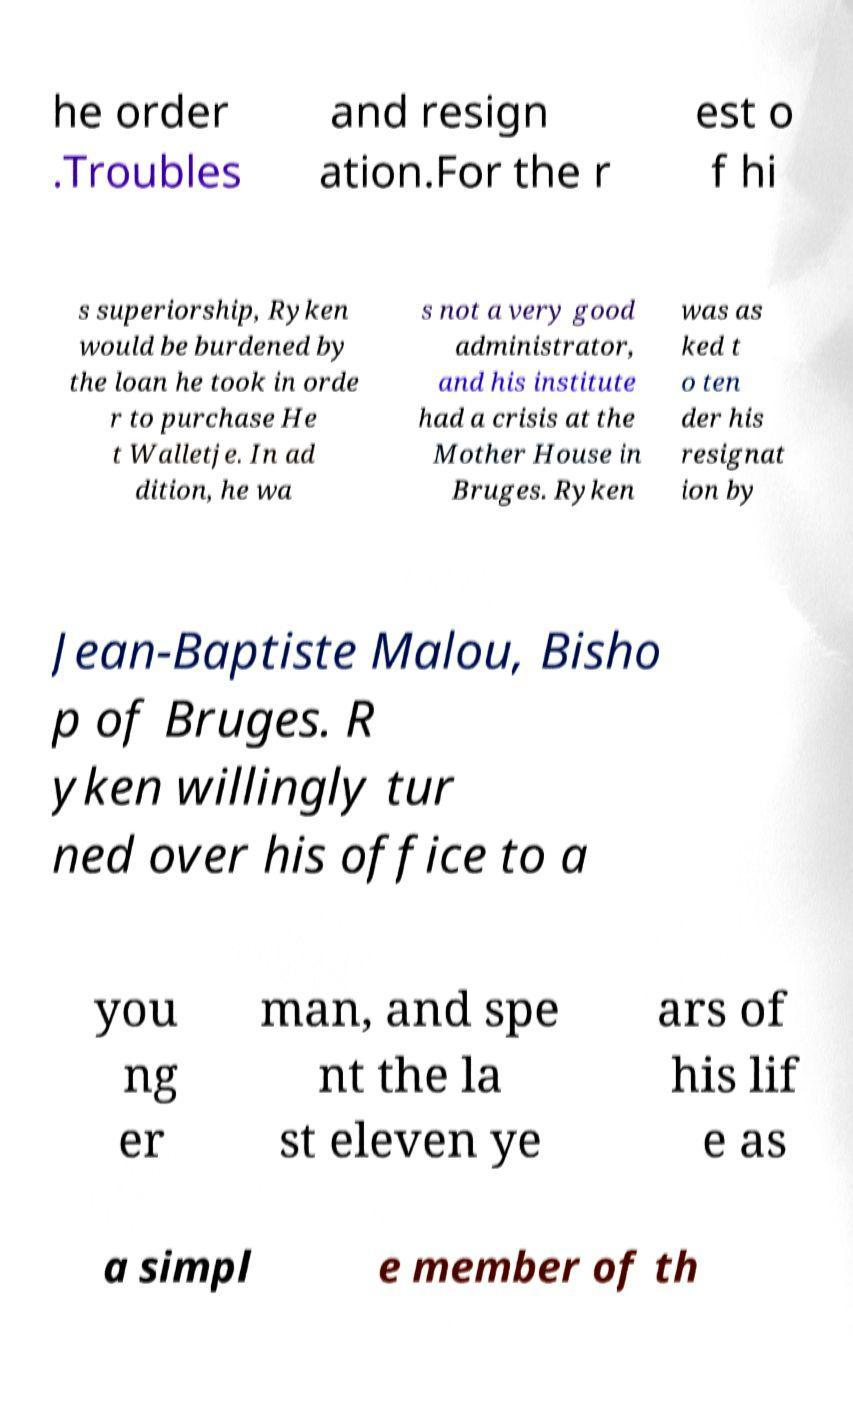Can you accurately transcribe the text from the provided image for me? he order .Troubles and resign ation.For the r est o f hi s superiorship, Ryken would be burdened by the loan he took in orde r to purchase He t Walletje. In ad dition, he wa s not a very good administrator, and his institute had a crisis at the Mother House in Bruges. Ryken was as ked t o ten der his resignat ion by Jean-Baptiste Malou, Bisho p of Bruges. R yken willingly tur ned over his office to a you ng er man, and spe nt the la st eleven ye ars of his lif e as a simpl e member of th 